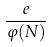Convert formula to latex. <formula><loc_0><loc_0><loc_500><loc_500>\frac { e } { \varphi ( N ) }</formula> 